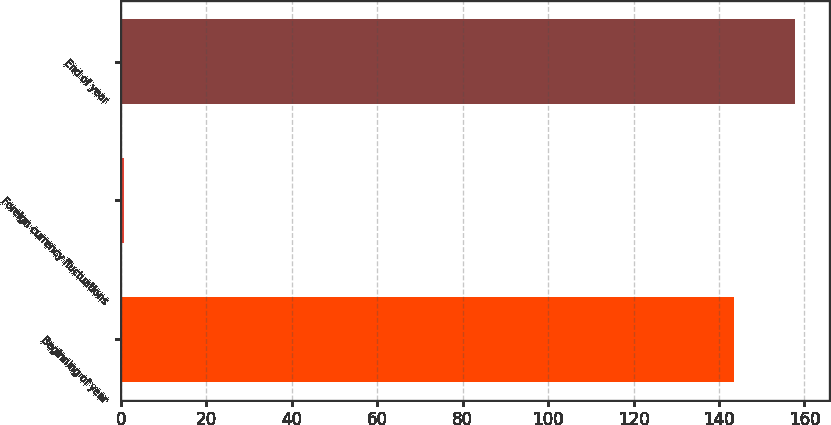<chart> <loc_0><loc_0><loc_500><loc_500><bar_chart><fcel>Beginning of year<fcel>Foreign currency fluctuations<fcel>End of year<nl><fcel>143.5<fcel>0.8<fcel>157.85<nl></chart> 